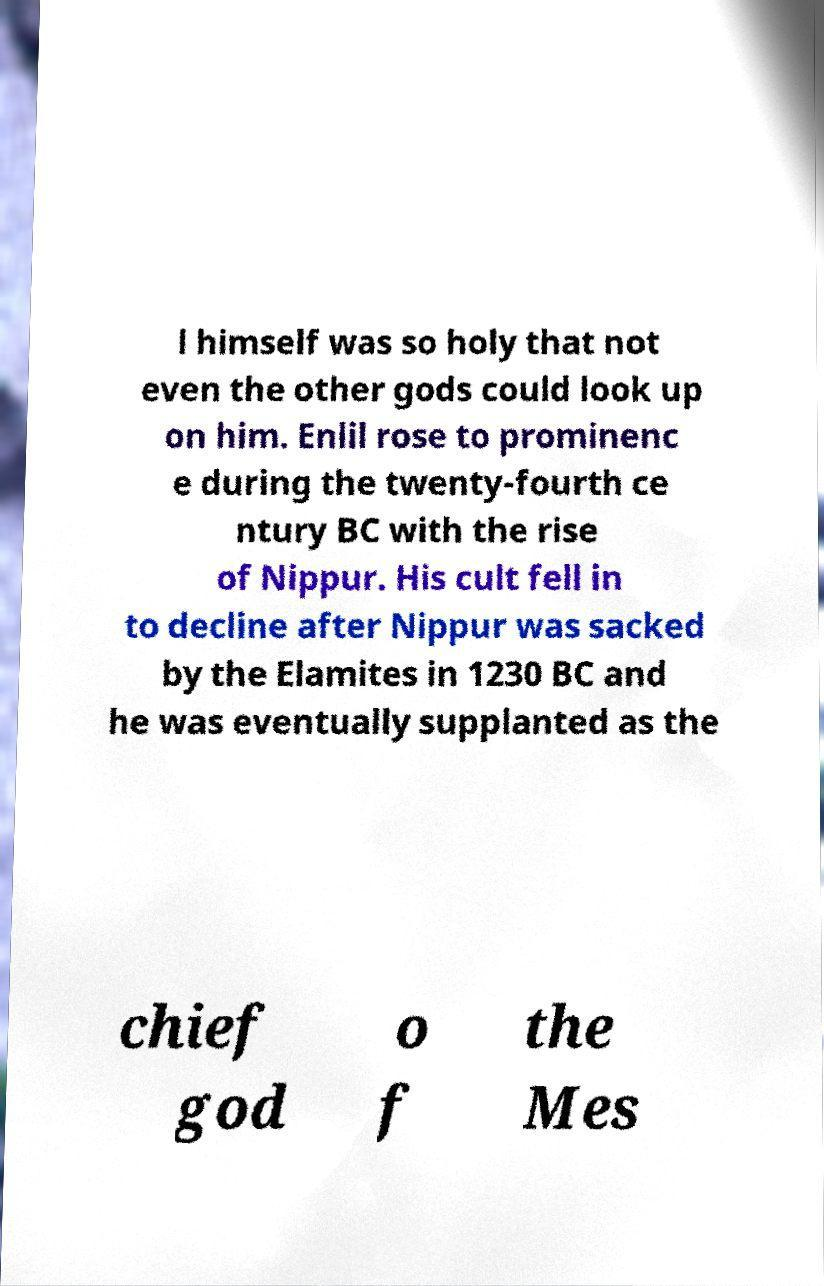Please identify and transcribe the text found in this image. l himself was so holy that not even the other gods could look up on him. Enlil rose to prominenc e during the twenty-fourth ce ntury BC with the rise of Nippur. His cult fell in to decline after Nippur was sacked by the Elamites in 1230 BC and he was eventually supplanted as the chief god o f the Mes 